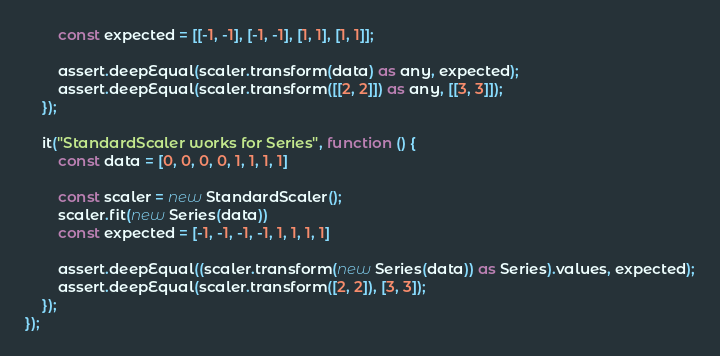<code> <loc_0><loc_0><loc_500><loc_500><_TypeScript_>        const expected = [[-1, -1], [-1, -1], [1, 1], [1, 1]];

        assert.deepEqual(scaler.transform(data) as any, expected);
        assert.deepEqual(scaler.transform([[2, 2]]) as any, [[3, 3]]);
    });

    it("StandardScaler works for Series", function () {
        const data = [0, 0, 0, 0, 1, 1, 1, 1]

        const scaler = new StandardScaler();
        scaler.fit(new Series(data))
        const expected = [-1, -1, -1, -1, 1, 1, 1, 1]

        assert.deepEqual((scaler.transform(new Series(data)) as Series).values, expected);
        assert.deepEqual(scaler.transform([2, 2]), [3, 3]);
    });
});
</code> 